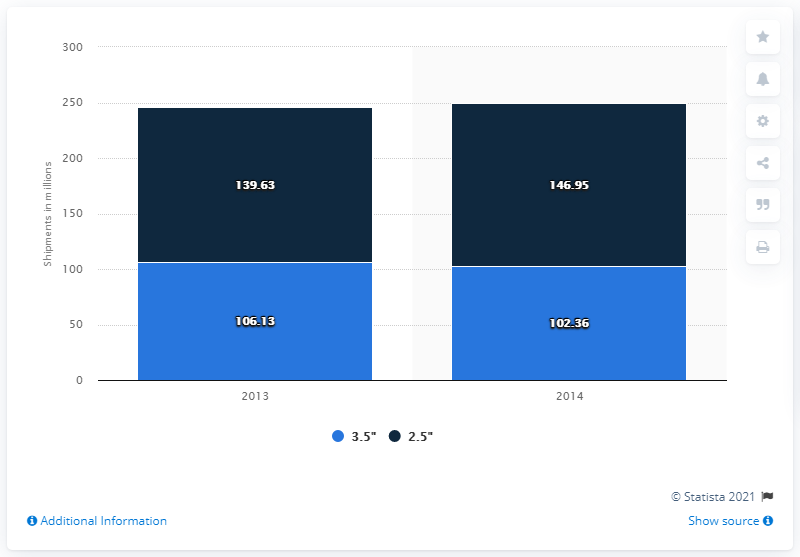Which year has he highest value?
 2014 